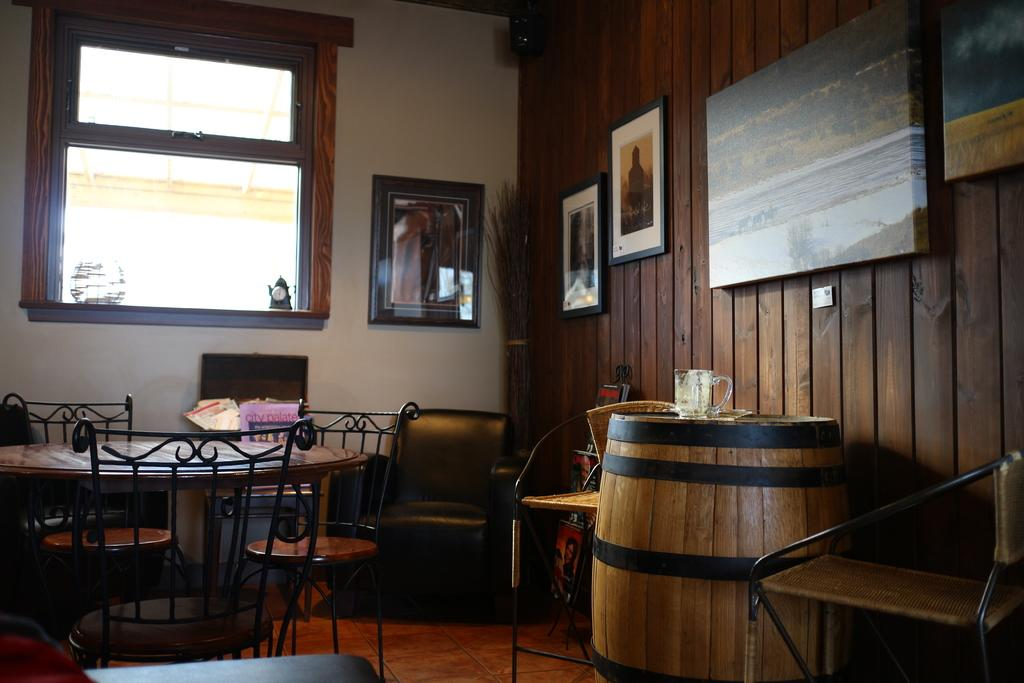What type of space is depicted in the image? The image shows an inner view of a room. What objects can be seen in the room? There is a barrel, a cup, photo frames on the wall, and chairs in the room. What type of humor is the woman in the image displaying? There is no woman present in the image, so it is not possible to determine what type of humor she might be displaying. 